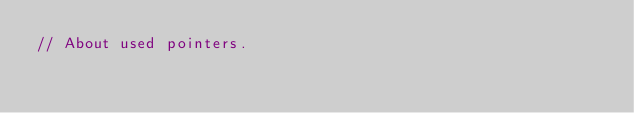Convert code to text. <code><loc_0><loc_0><loc_500><loc_500><_Go_>// About used pointers.</code> 